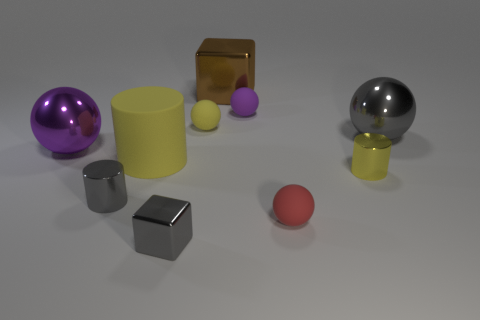What number of tiny metal things are there?
Offer a terse response. 3. Do the big brown object and the purple sphere on the left side of the small gray shiny cylinder have the same material?
Your answer should be very brief. Yes. There is a large sphere that is the same color as the tiny cube; what is its material?
Offer a very short reply. Metal. How many small balls have the same color as the large cylinder?
Ensure brevity in your answer.  1. What is the size of the brown thing?
Your answer should be very brief. Large. There is a large gray metal thing; does it have the same shape as the small yellow object that is on the left side of the red sphere?
Give a very brief answer. Yes. The big block that is the same material as the tiny yellow cylinder is what color?
Offer a terse response. Brown. There is a gray thing that is behind the big purple object; what size is it?
Your response must be concise. Large. Is the number of large purple balls behind the tiny purple rubber thing less than the number of large purple metallic objects?
Offer a terse response. Yes. Is the number of purple rubber blocks less than the number of small purple rubber objects?
Offer a very short reply. Yes. 